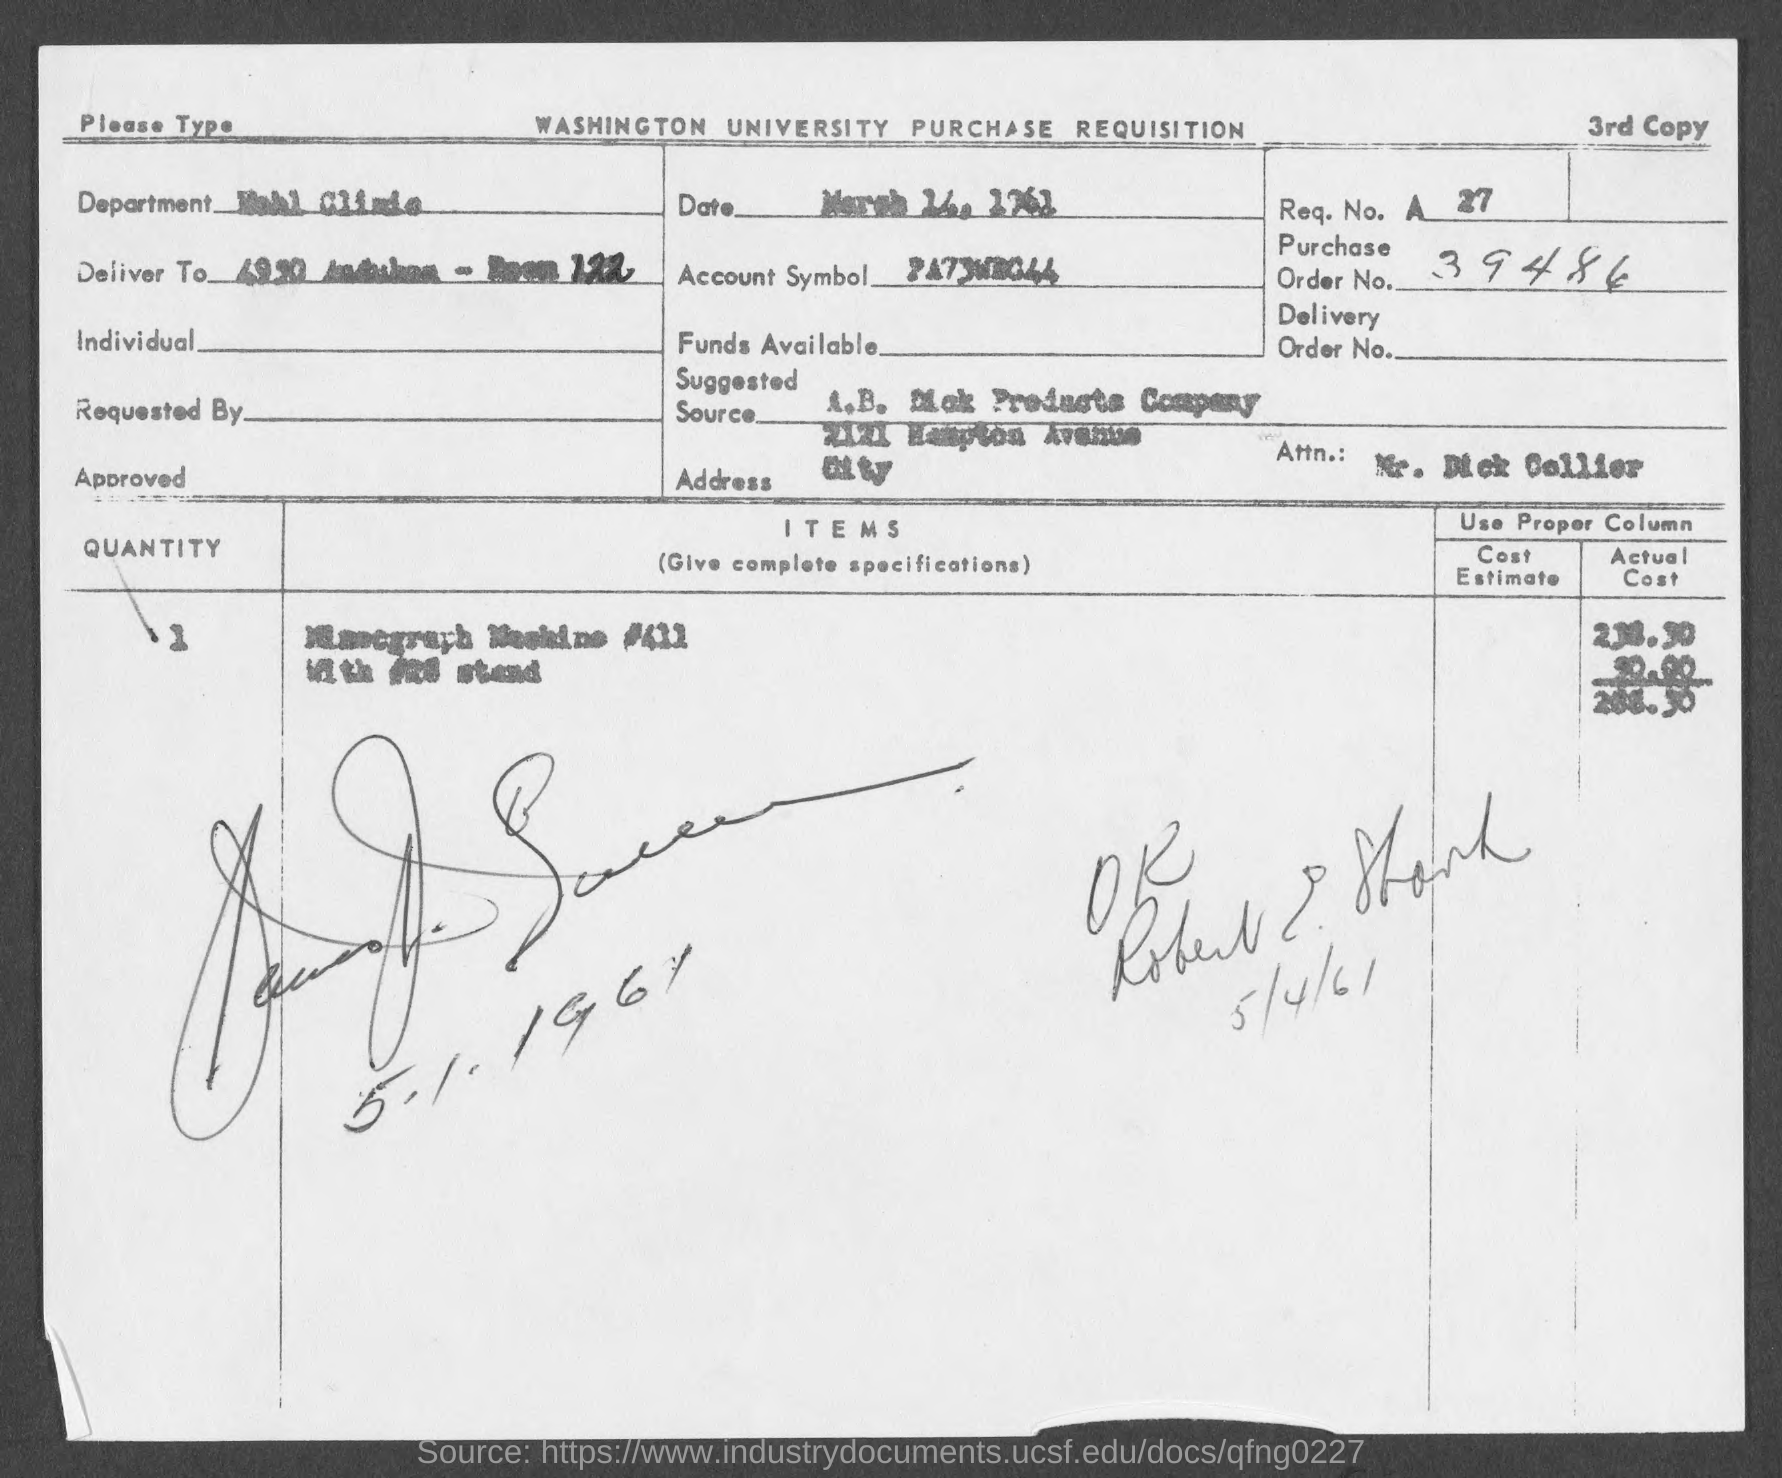Identify some key points in this picture. The document contains a request number of 27. The document contains the purchase order number 39486. 